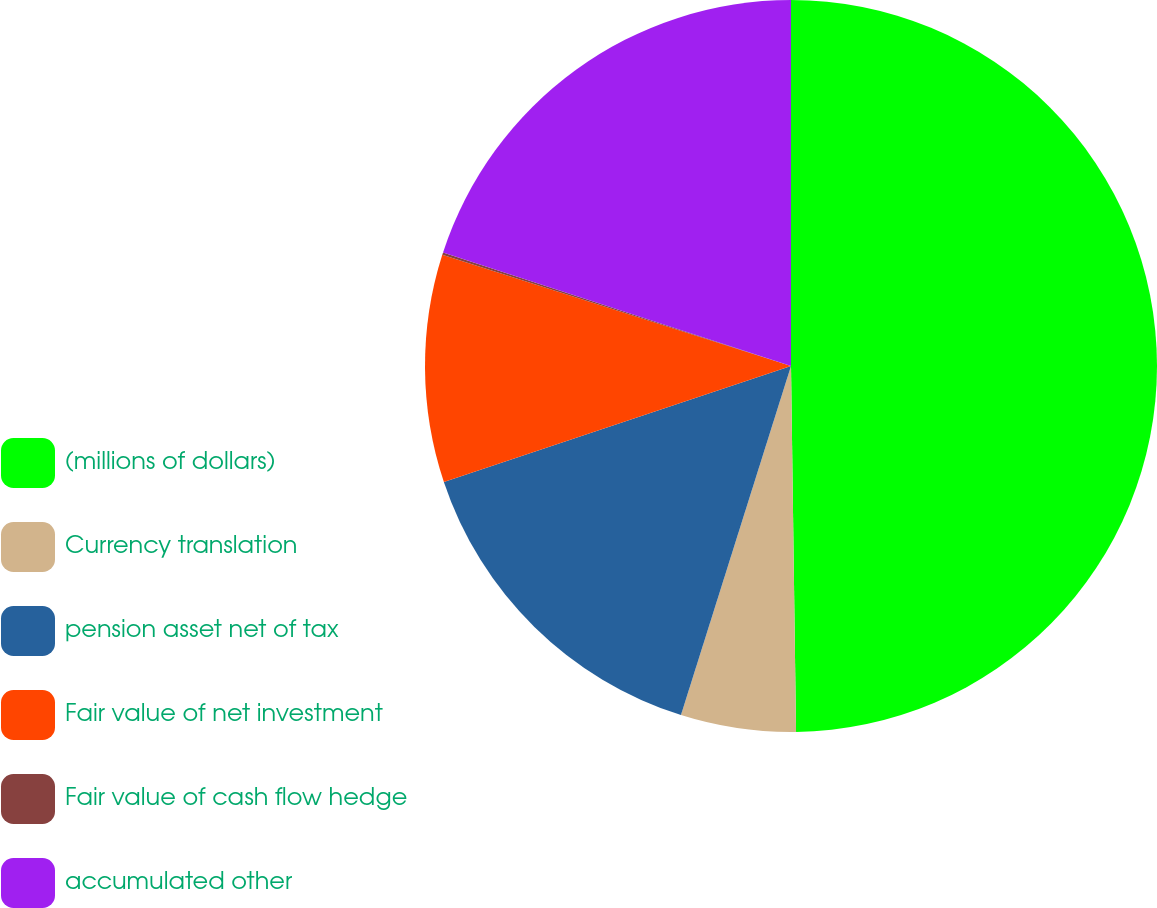Convert chart to OTSL. <chart><loc_0><loc_0><loc_500><loc_500><pie_chart><fcel>(millions of dollars)<fcel>Currency translation<fcel>pension asset net of tax<fcel>Fair value of net investment<fcel>Fair value of cash flow hedge<fcel>accumulated other<nl><fcel>49.78%<fcel>5.08%<fcel>15.01%<fcel>10.04%<fcel>0.11%<fcel>19.98%<nl></chart> 